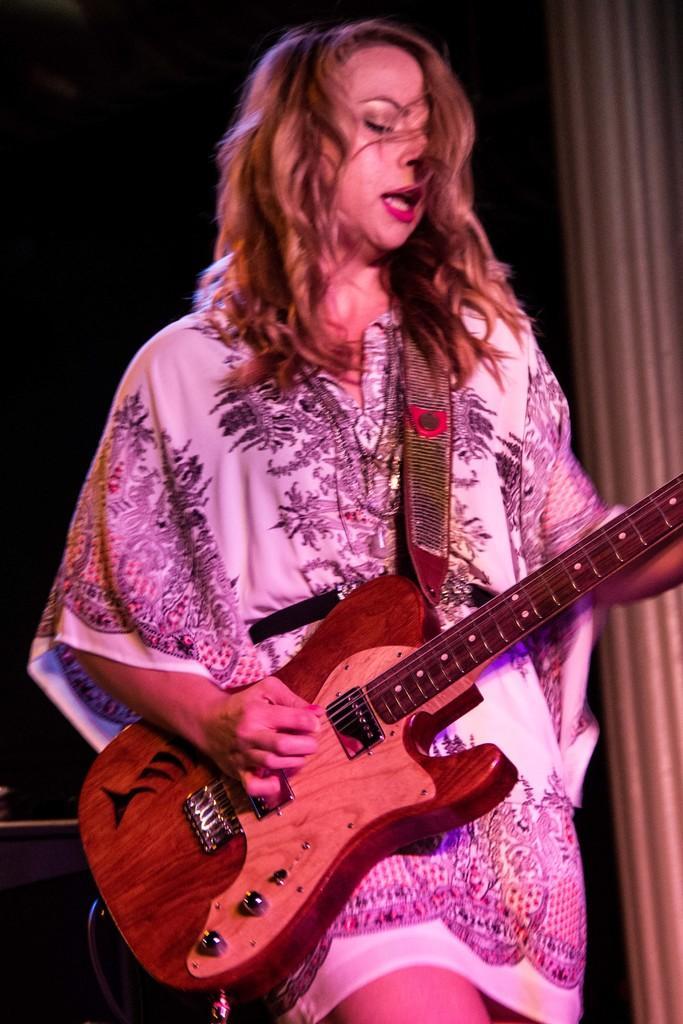How would you summarize this image in a sentence or two? In this image we can see a lady holding a guitar in her hands and playing it. The background is dark. 